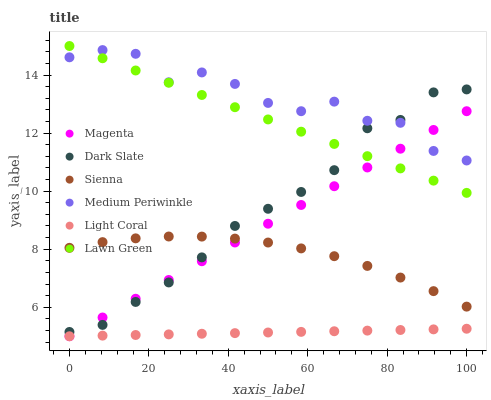Does Light Coral have the minimum area under the curve?
Answer yes or no. Yes. Does Medium Periwinkle have the maximum area under the curve?
Answer yes or no. Yes. Does Lawn Green have the minimum area under the curve?
Answer yes or no. No. Does Lawn Green have the maximum area under the curve?
Answer yes or no. No. Is Light Coral the smoothest?
Answer yes or no. Yes. Is Medium Periwinkle the roughest?
Answer yes or no. Yes. Is Lawn Green the smoothest?
Answer yes or no. No. Is Lawn Green the roughest?
Answer yes or no. No. Does Light Coral have the lowest value?
Answer yes or no. Yes. Does Lawn Green have the lowest value?
Answer yes or no. No. Does Lawn Green have the highest value?
Answer yes or no. Yes. Does Medium Periwinkle have the highest value?
Answer yes or no. No. Is Light Coral less than Dark Slate?
Answer yes or no. Yes. Is Medium Periwinkle greater than Sienna?
Answer yes or no. Yes. Does Magenta intersect Sienna?
Answer yes or no. Yes. Is Magenta less than Sienna?
Answer yes or no. No. Is Magenta greater than Sienna?
Answer yes or no. No. Does Light Coral intersect Dark Slate?
Answer yes or no. No. 